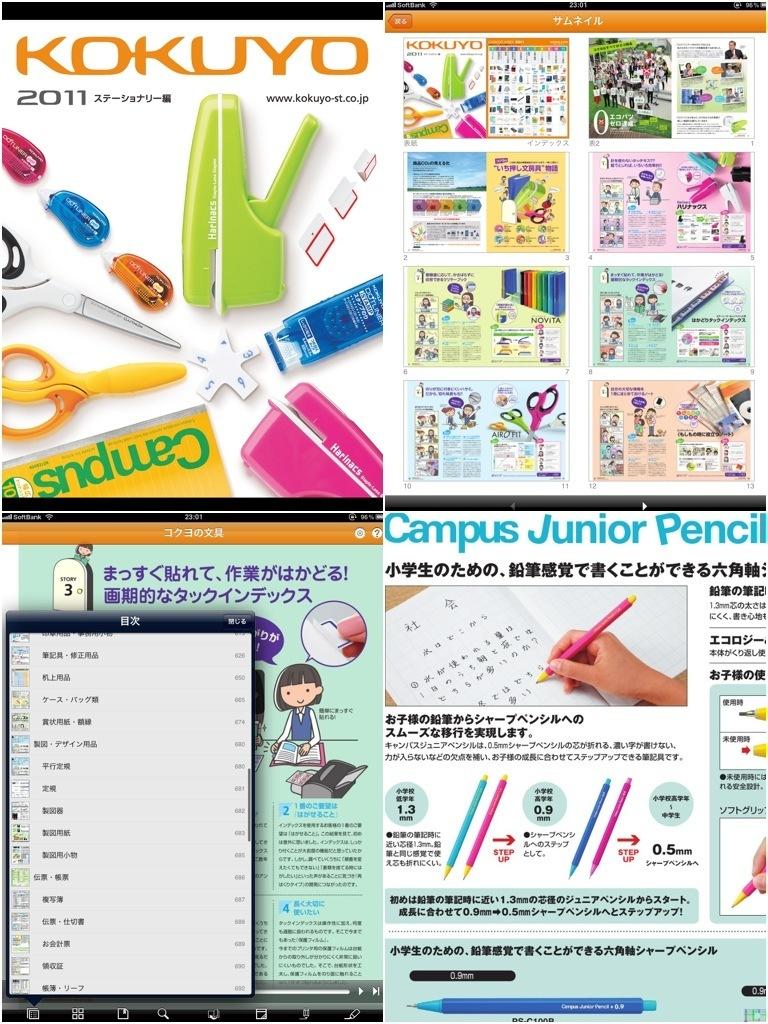What kind of pencil is it?
Provide a succinct answer. Campus junior. What year is the publication?
Your answer should be very brief. 2011. 